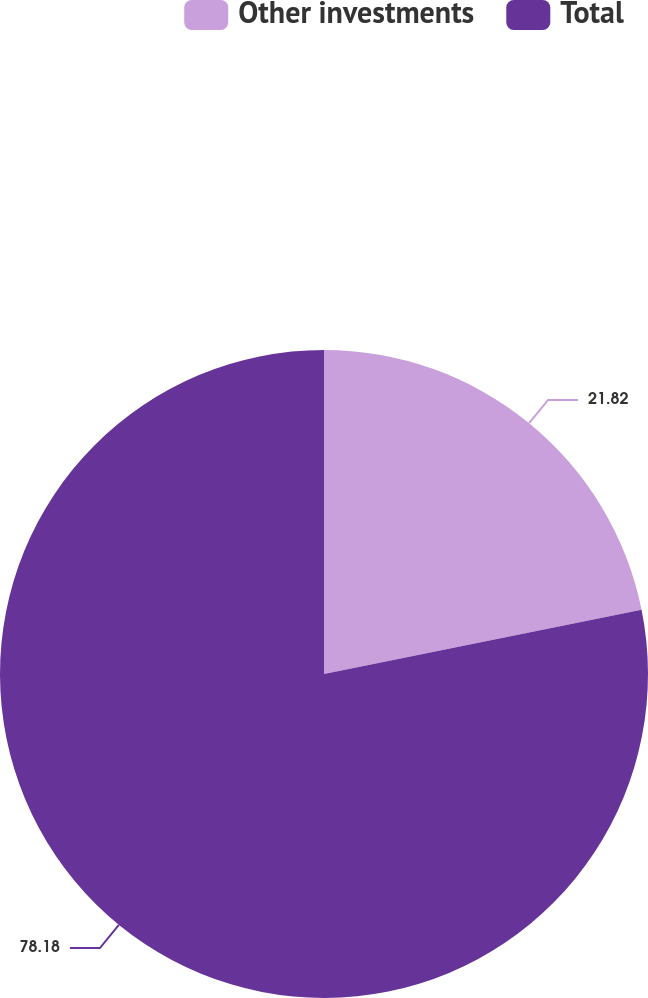Convert chart. <chart><loc_0><loc_0><loc_500><loc_500><pie_chart><fcel>Other investments<fcel>Total<nl><fcel>21.82%<fcel>78.18%<nl></chart> 